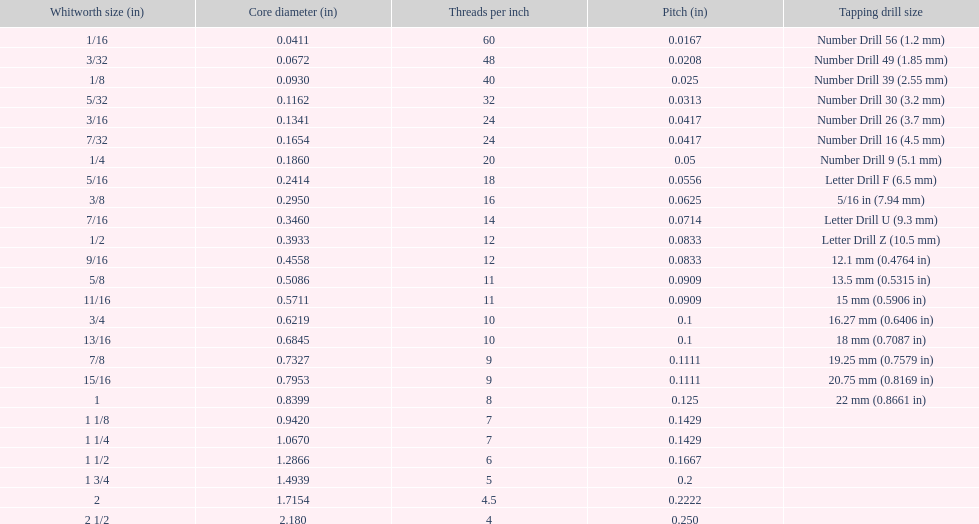What is the fundamental diameter for the number drill 26? 0.1341. What is the whitworth size (in) for this fundamental diameter? 3/16. 